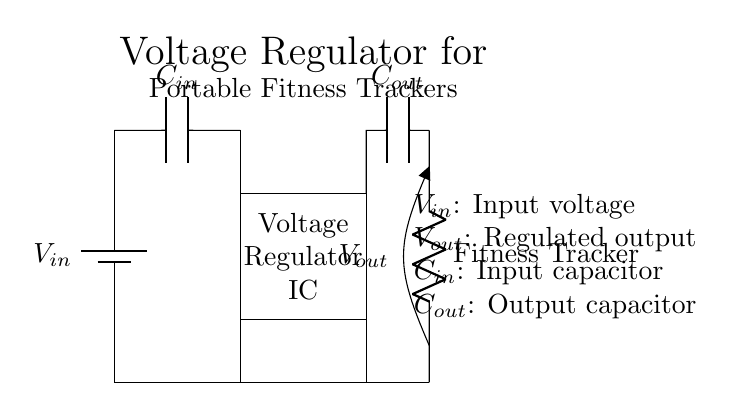What is the input voltage in the circuit? The input voltage is represented as V_in in the circuit schematic, typically supplied by a battery.
Answer: V_in What type of capacitors are used in the circuit? The circuit includes two capacitors: C_in as the input capacitor and C_out as the output capacitor, specifically for stabilizing voltage levels.
Answer: C_in and C_out What does the load resistor represent in this circuit? The load resistor connected at the output represents the fitness tracker, indicating the device that will draw current from the regulated output voltage.
Answer: Fitness Tracker What is the purpose of the voltage regulator IC? The voltage regulator IC adjusts and maintains a constant output voltage despite variations in input voltage or load conditions, ensuring reliable operation of the fitness tracking device.
Answer: Regulates voltage How does the output capacitor function in the circuit? The output capacitor helps to smooth out the voltage at the output, reducing voltage ripple and providing stable power to the load (fitness tracker).
Answer: Smoothing voltage What is the output voltage in the circuit? The output voltage is indicated as V_out and represents the regulated voltage provided to the device, ensuring it operates within specified parameters.
Answer: V_out 